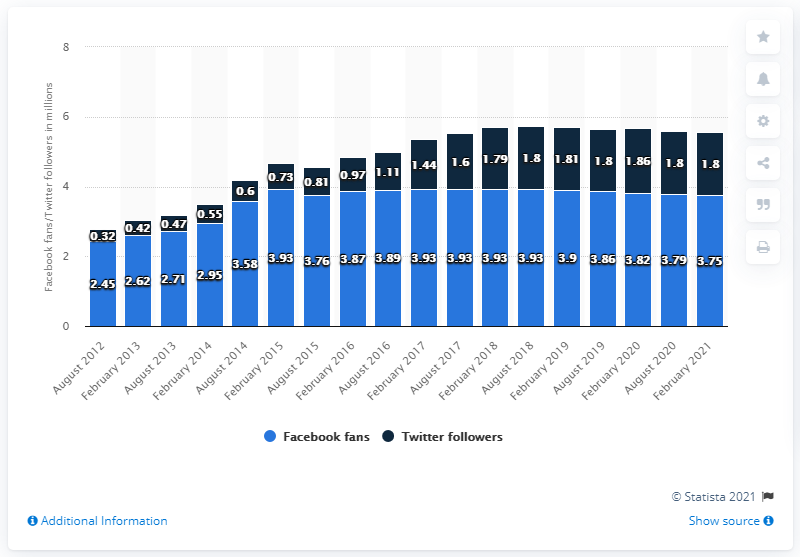Outline some significant characteristics in this image. The highest value of navy blue bars recorded over the years is 1.8. In February 2021, the discrepancy between the number of Facebook fans and Twitter followers was at its smallest. In February 2021, the New York Giants football team had 3.75 million Facebook followers. 